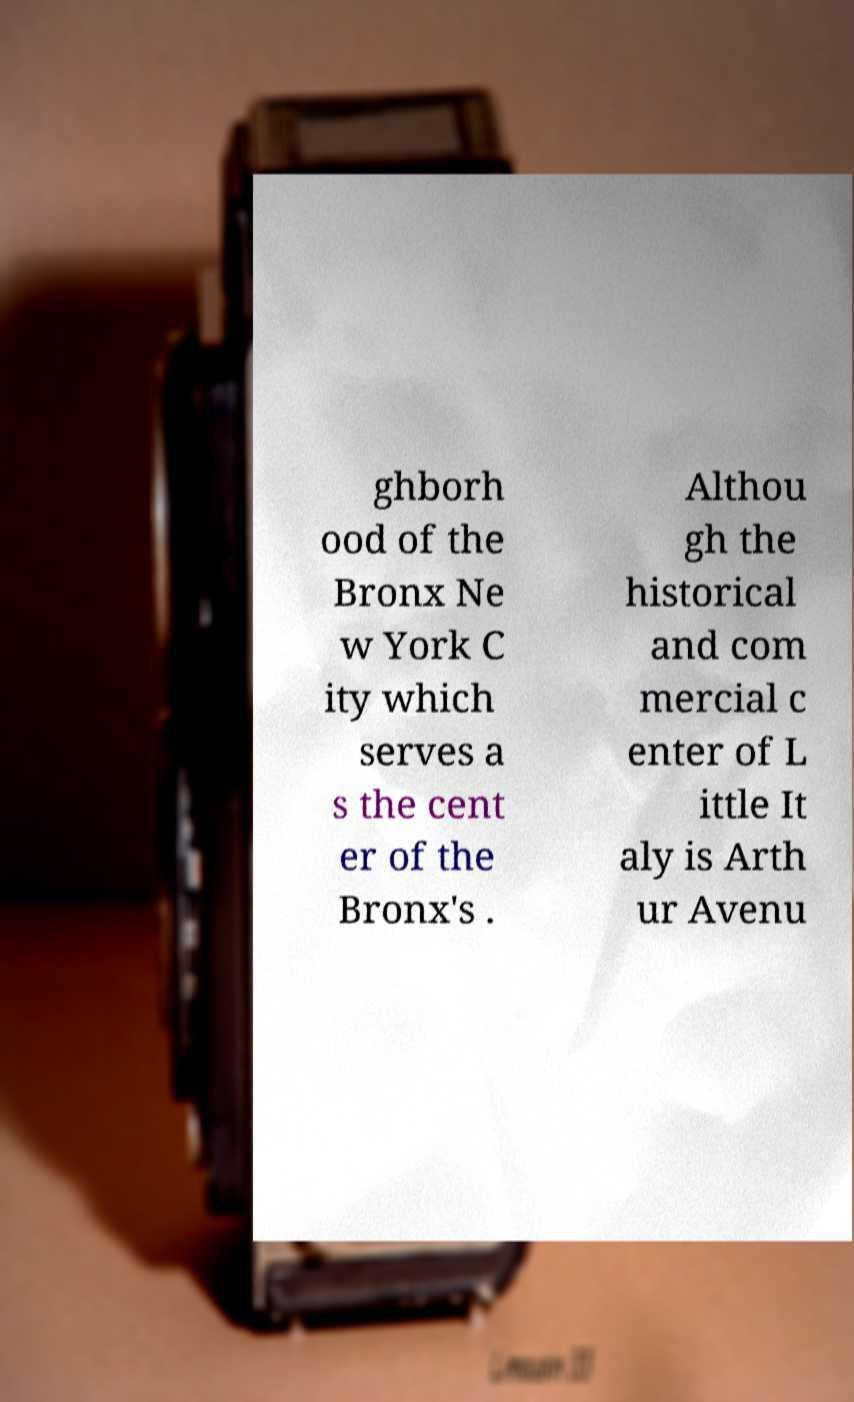Could you extract and type out the text from this image? ghborh ood of the Bronx Ne w York C ity which serves a s the cent er of the Bronx's . Althou gh the historical and com mercial c enter of L ittle It aly is Arth ur Avenu 